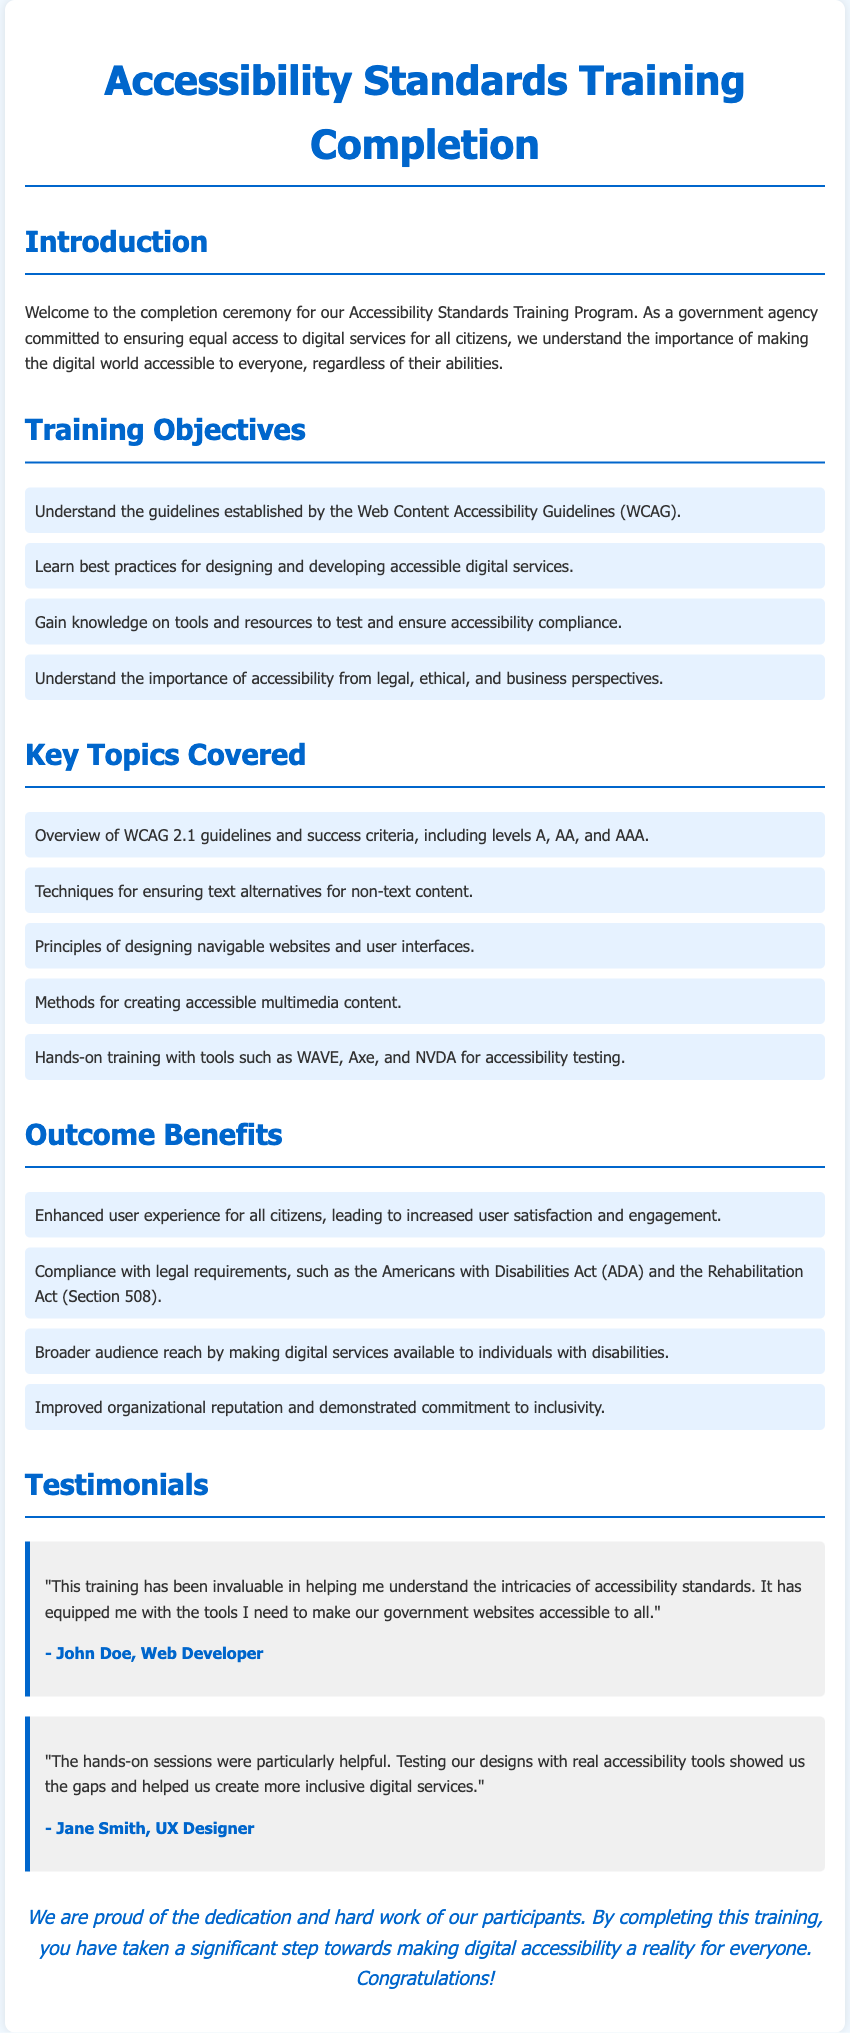What is the title of the document? The title of the document is presented as the main heading, which is "Accessibility Standards Training Completion."
Answer: Accessibility Standards Training Completion What is the first training objective listed? The first objective is explicitly mentioned in the document as the first bullet point under Training Objectives.
Answer: Understand the guidelines established by the Web Content Accessibility Guidelines (WCAG) What are the levels of WCAG mentioned in the key topics? The levels are stated under the key topics section, specifically mentioning levels A, AA, and AAA.
Answer: A, AA, and AAA Who is the testimonial author for the first testimonial? The author is provided at the end of the first testimonial section, identified as John Doe.
Answer: John Doe What is one outcome benefit of completing the training? The benefits are listed in the Outcome Benefits section; one is "Enhanced user experience for all citizens."
Answer: Enhanced user experience for all citizens What are the names of two accessibility testing tools mentioned in the document? The tools are listed together in the key topics section; two of them are WAVE and Axe.
Answer: WAVE, Axe What is the main goal of the government agency as stated in the introduction? The main goal is articulated in the introduction paragraph of the document, emphasizing equal access to digital services.
Answer: Ensuring equal access to digital services What type of professionals shared testimonials in the document? The professions can be identified from the closing section of the testimonials, specifically mentioning a Web Developer and a UX Designer.
Answer: Web Developer, UX Designer 